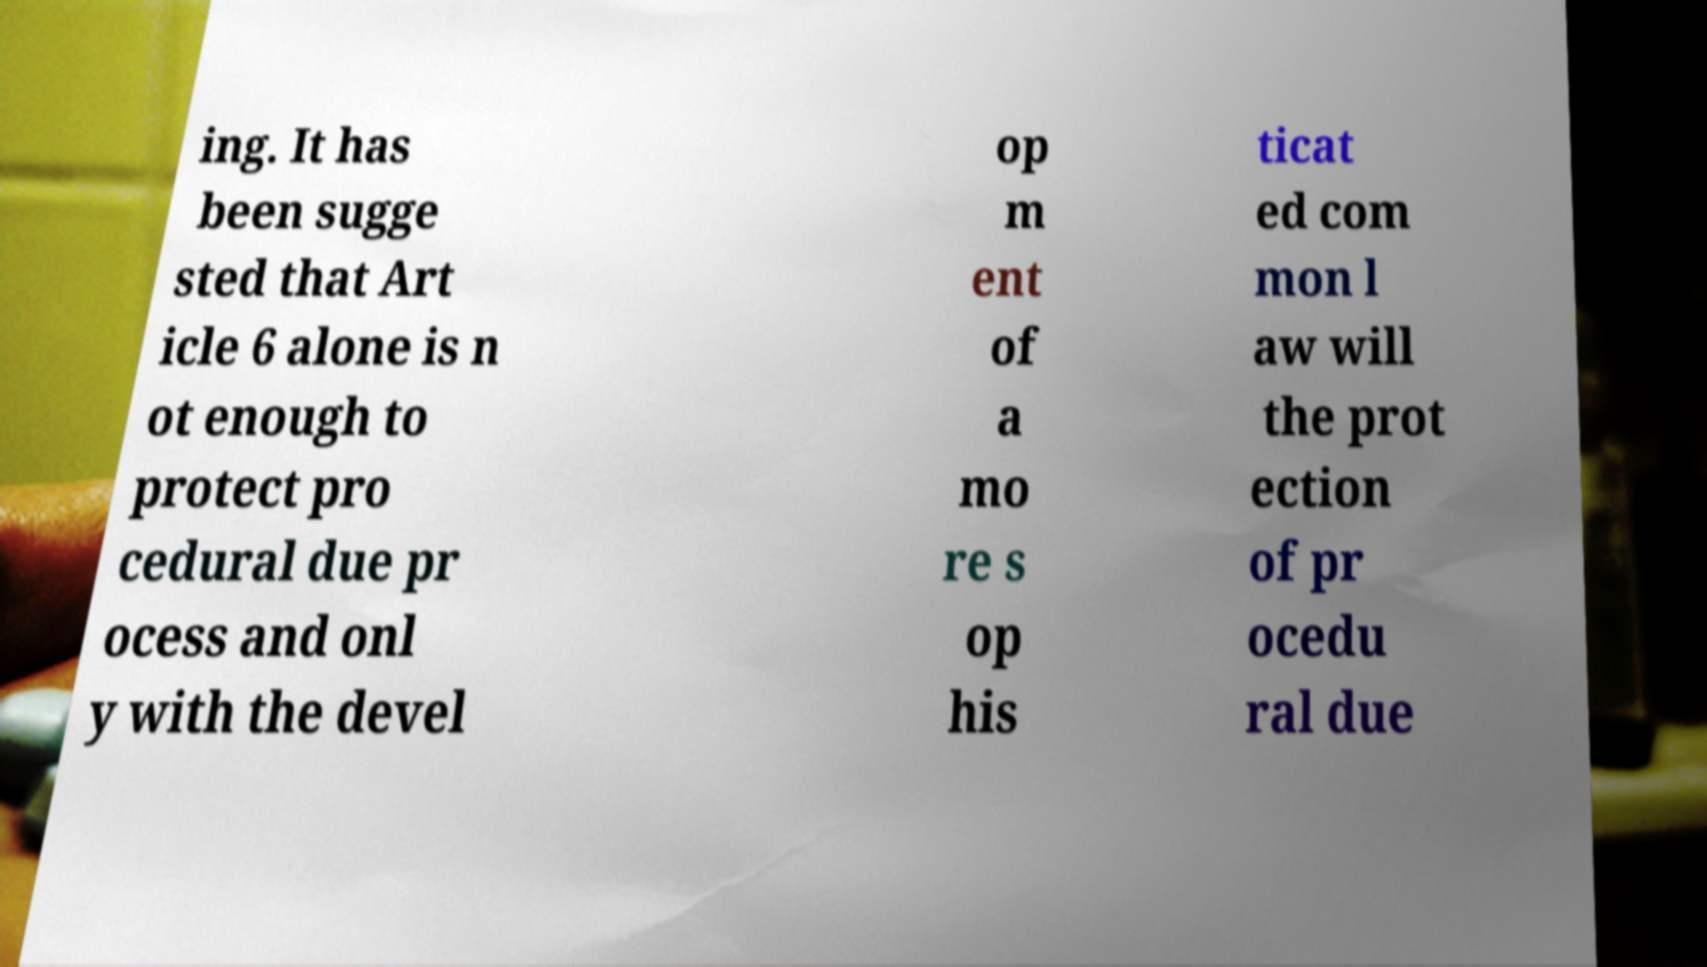Please identify and transcribe the text found in this image. ing. It has been sugge sted that Art icle 6 alone is n ot enough to protect pro cedural due pr ocess and onl y with the devel op m ent of a mo re s op his ticat ed com mon l aw will the prot ection of pr ocedu ral due 